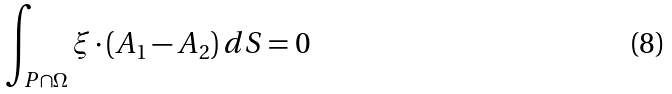Convert formula to latex. <formula><loc_0><loc_0><loc_500><loc_500>\int _ { P \cap \Omega } \xi \cdot ( A _ { 1 } - A _ { 2 } ) \, d S = 0</formula> 